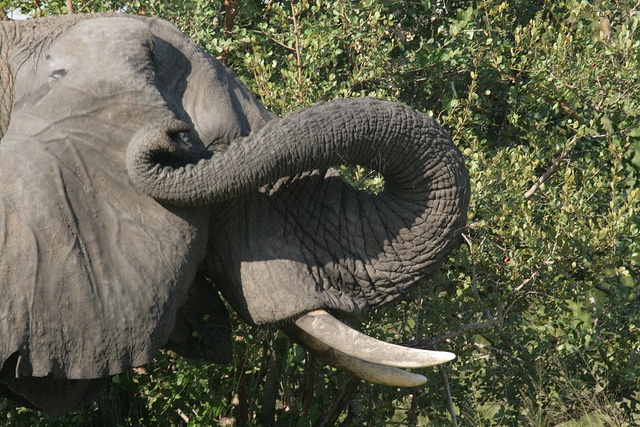Describe the objects in this image and their specific colors. I can see a elephant in gray, black, and darkgray tones in this image. 